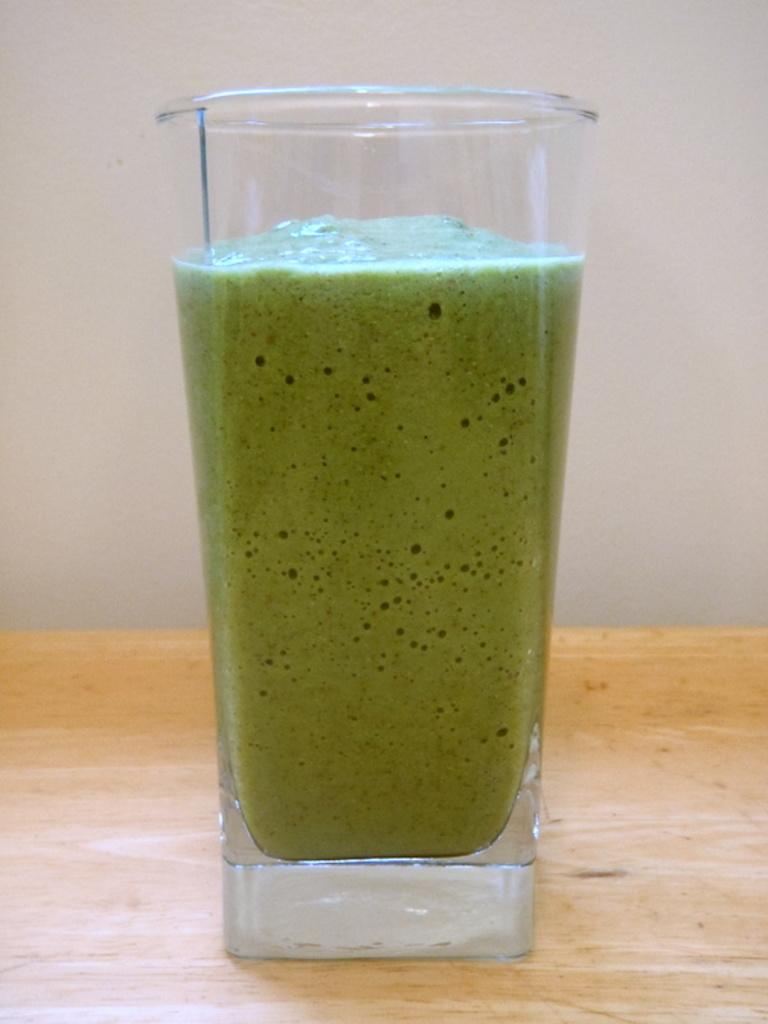What is in the glass that is visible in the image? There is a glass of juice in the image. Where is the glass of juice located in the image? The glass of juice is present on a table. What book is the child reading in the image? There is no child or book present in the image; it only features a glass of juice on a table. 